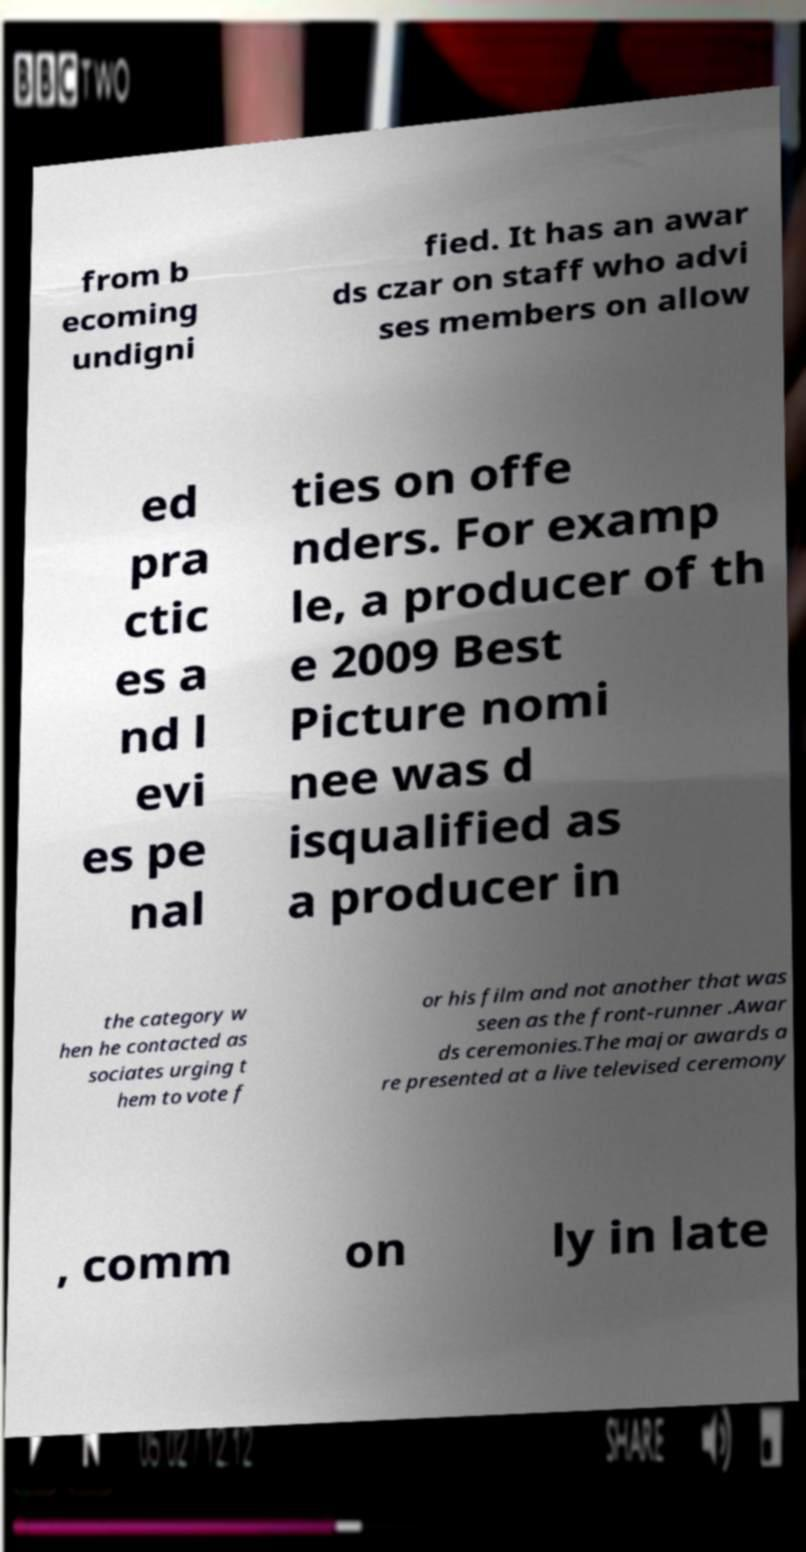For documentation purposes, I need the text within this image transcribed. Could you provide that? from b ecoming undigni fied. It has an awar ds czar on staff who advi ses members on allow ed pra ctic es a nd l evi es pe nal ties on offe nders. For examp le, a producer of th e 2009 Best Picture nomi nee was d isqualified as a producer in the category w hen he contacted as sociates urging t hem to vote f or his film and not another that was seen as the front-runner .Awar ds ceremonies.The major awards a re presented at a live televised ceremony , comm on ly in late 